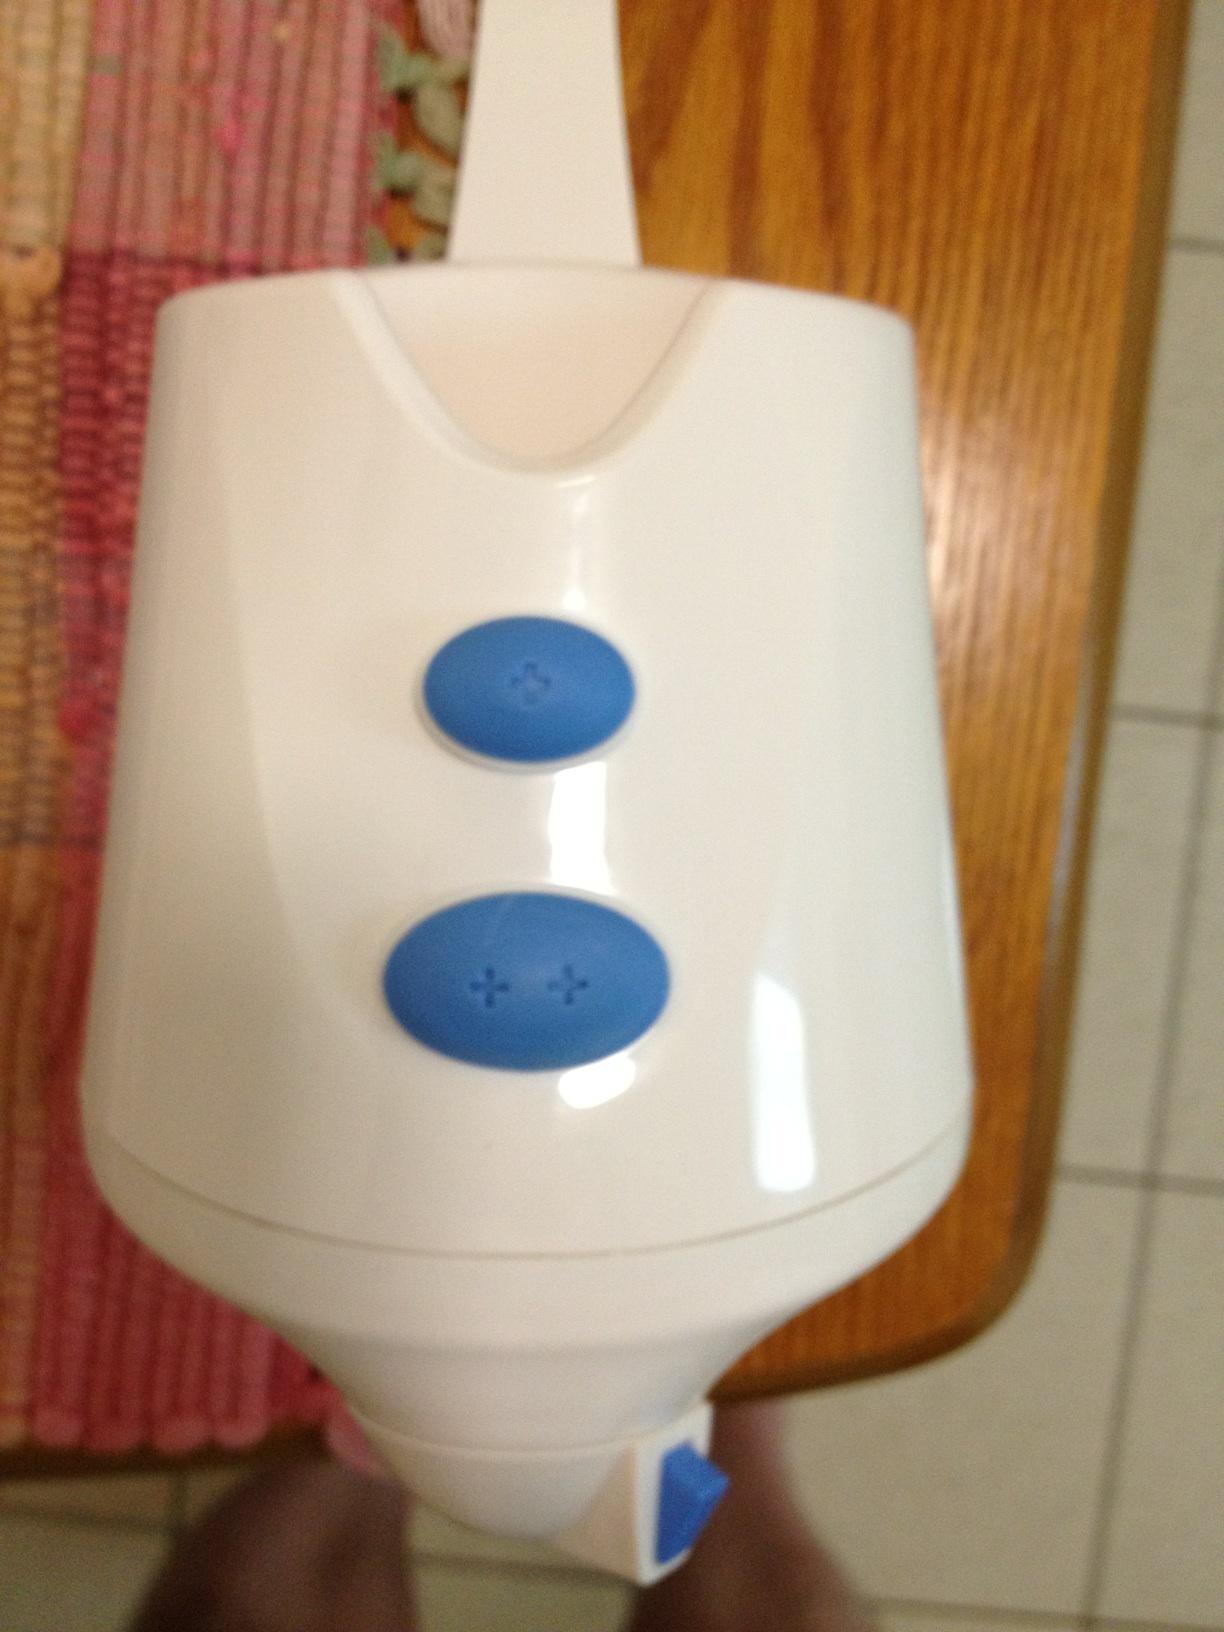Imagine if this device had a secret function. What could it be? What if this seemingly ordinary appliance had a hidden feature that allowed it to communicate with your other smart devices? Imagine pressing the plus button three times, and it opens a holographic interface where you can control your entire smart home, from lights to security systems! Can you describe a scenario where this secret function would be really useful? Absolutely! Picture this: it's a chilly evening, and you're curled up on the couch with a good book. With the secret function, you press the button, and suddenly a holographic interface appears. You adjust the thermostat to warm the room, dim the lights to a cozy ambiance, and turn on some soft background music. All without leaving your comfortable spot! 